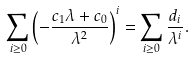Convert formula to latex. <formula><loc_0><loc_0><loc_500><loc_500>\sum _ { i \geq 0 } \left ( - \frac { c _ { 1 } \lambda + c _ { 0 } } { \lambda ^ { 2 } } \right ) ^ { i } = \sum _ { i \geq 0 } \frac { d _ { i } } { \lambda ^ { i } } .</formula> 